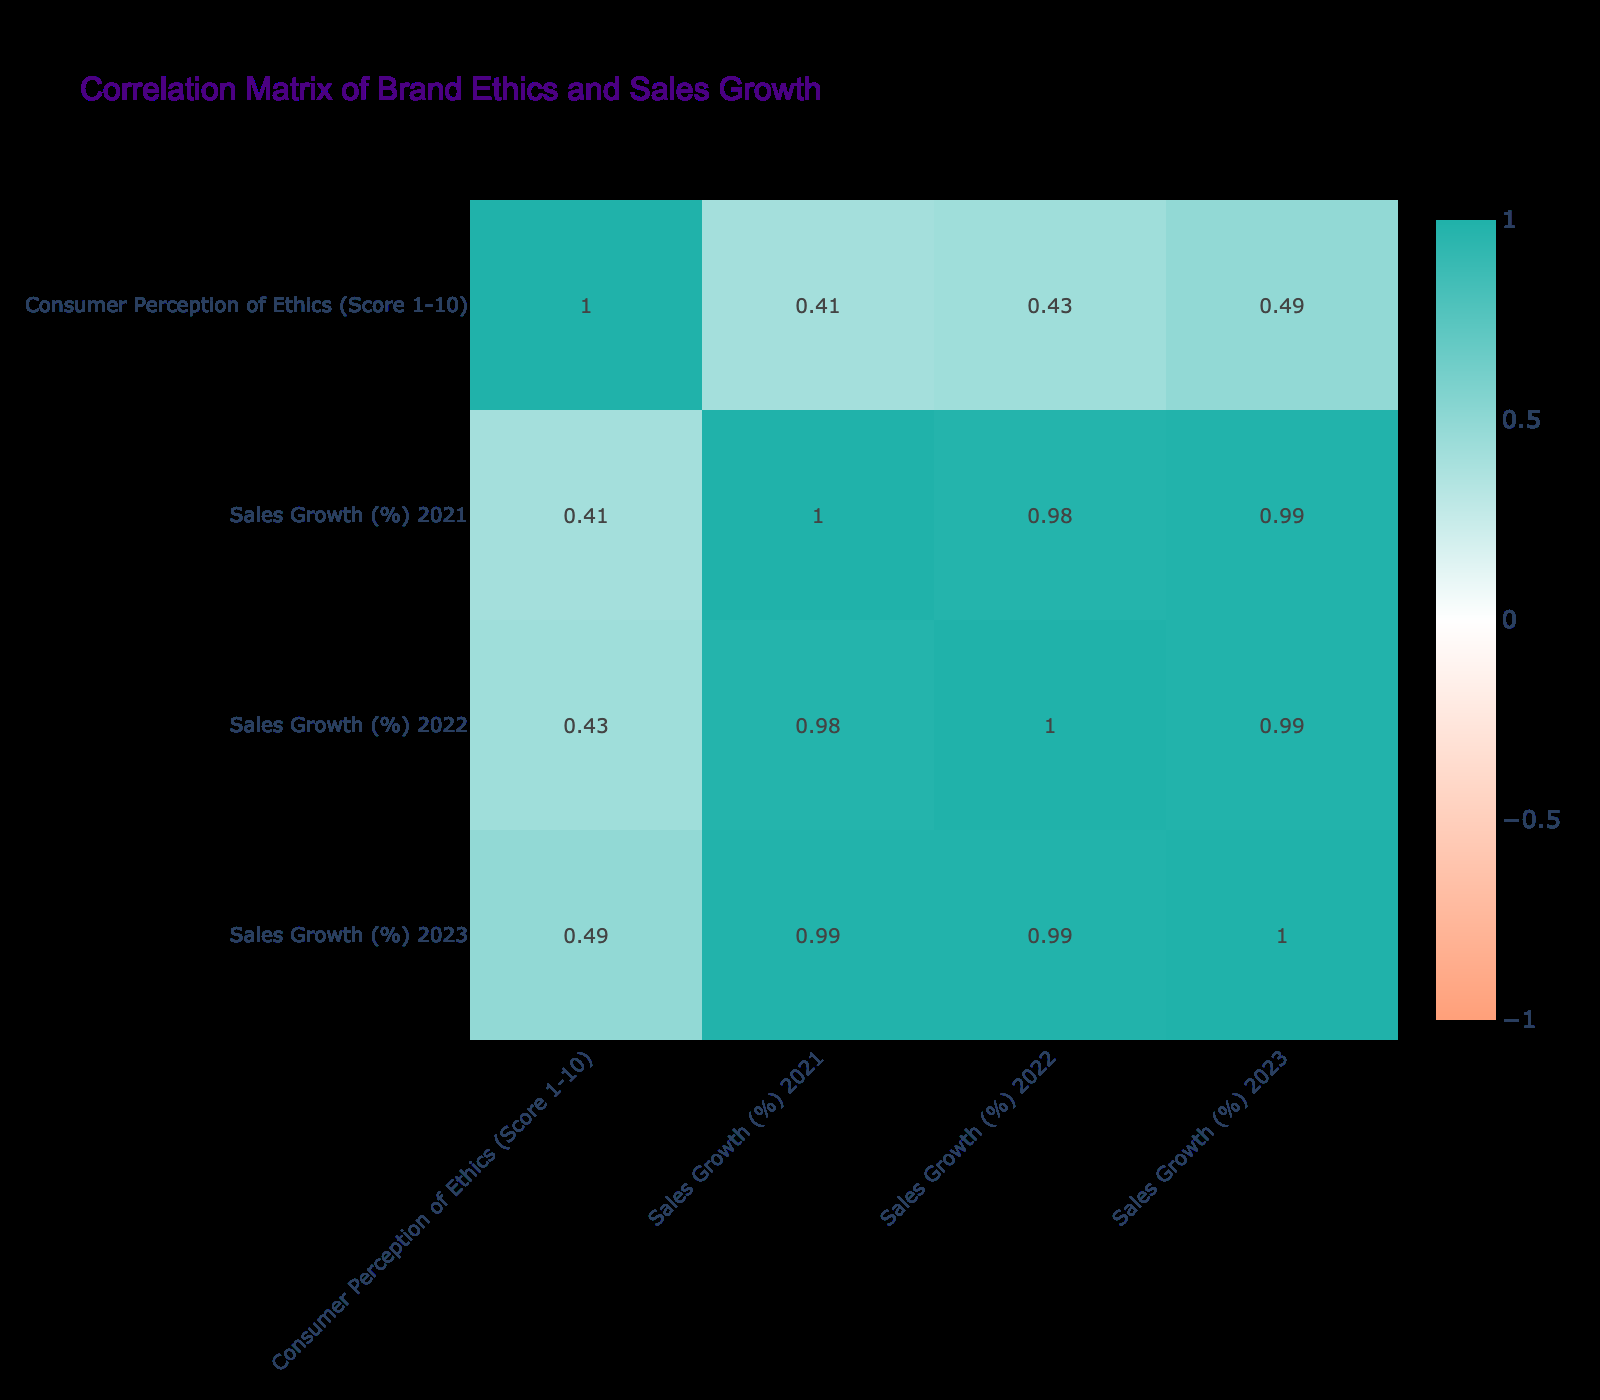What is the correlation between consumer perception of ethics and sales growth for Apple? Apple has a consumer perception score of 9 and had sales growth percentages of 7.5%, 8.2%, and 9.0% over the years 2021, 2022, and 2023 respectively. To check the correlation, we consider Apple’s scores and sales growth values from the table and observe that they increase together, indicating a positive relationship.
Answer: Positive correlation Which brand had the highest sales growth in 2022? Looking at the sales growth percentages for 2022 across all brands, Nvidia stands out with a sales growth of 25%. This can be confirmed by reviewing the sales growth figures listed for each brand for that year.
Answer: Nvidia What is the average consumer perception of ethics score for the listed brands? To find the average consumer perception score, we total the individual scores for all brands: 9 + 8 + 8 + 7 + 9 + 6 + 7 + 8 + 9 + 8 = 79. There are 10 brands, so we calculate the average: 79 / 10 = 7.9.
Answer: 7.9 Is there any brand with a consumer perception of ethics score lower than 7? The only brand with a score lower than 7 is Facebook, which has a score of 6. This can be quickly verified by scanning the consumer perception column of the table.
Answer: Yes Which brands have a consumer perception of ethics score of 8 or higher? The brands with a score of 8 or higher are Apple, Samsung, Microsoft, Intel, IBM, Nvidia, and Tesla. To derive this, I list the scores from the consumer perception column and only include those with scores of 8 or more.
Answer: Apple, Samsung, Microsoft, Intel, IBM, Nvidia, Tesla What was the sales growth difference between Microsoft in 2021 and Facebook in 2022? Microsoft had a sales growth of 10.0% in 2021 and Facebook had 3.0% in 2022. The difference is calculated by subtracting Facebook's sales growth from Microsoft's: 10.0% - 3.0% = 7.0%.
Answer: 7.0% How does Tesla’s sales growth in 2023 compare to Apple’s sales growth in the same year? Tesla's sales growth in 2023 is 14.5% while Apple's is 9.0%. We can compare these two values directly from the table: 14.5% (Tesla) is greater than 9.0% (Apple), indicating Tesla outperformed Apple in sales growth that year.
Answer: Tesla's sales growth is higher Do any brands show a decline in sales growth from 2022 to 2023? By examining the sales growth percentages for 2022 and 2023, we can see that both Facebook and Samsung show a decline, with Facebook dropping from 3.0% to 1.5% and Samsung from 6.5% to 5.8%. Hence, both brands experienced a decrease in sales growth.
Answer: Yes What is the highest consumer perception score among the brands listed? Scanning the consumer perception scores, Apple, Tesla, and IBM all score 9, which is the highest score in the table. This observation leads to the conclusion that these brands share the top score.
Answer: 9 